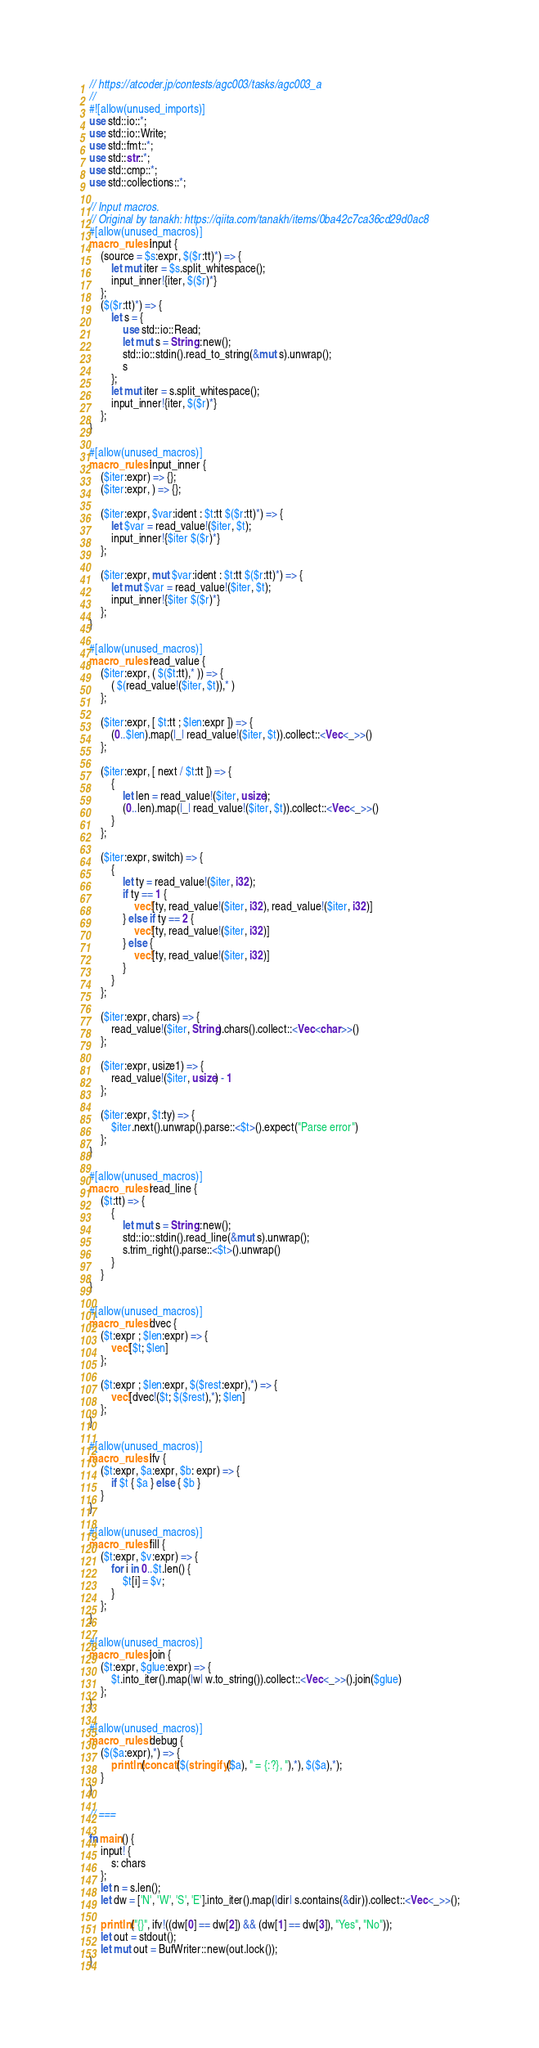Convert code to text. <code><loc_0><loc_0><loc_500><loc_500><_Rust_>// https://atcoder.jp/contests/agc003/tasks/agc003_a
//
#![allow(unused_imports)]
use std::io::*;
use std::io::Write;
use std::fmt::*;
use std::str::*;
use std::cmp::*;
use std::collections::*;

// Input macros.
// Original by tanakh: https://qiita.com/tanakh/items/0ba42c7ca36cd29d0ac8
#[allow(unused_macros)]
macro_rules! input {
    (source = $s:expr, $($r:tt)*) => {
        let mut iter = $s.split_whitespace();
        input_inner!{iter, $($r)*}
    };
    ($($r:tt)*) => {
        let s = {
            use std::io::Read;
            let mut s = String::new();
            std::io::stdin().read_to_string(&mut s).unwrap();
            s
        };
        let mut iter = s.split_whitespace();
        input_inner!{iter, $($r)*}
    };
}

#[allow(unused_macros)]
macro_rules! input_inner {
    ($iter:expr) => {};
    ($iter:expr, ) => {};

    ($iter:expr, $var:ident : $t:tt $($r:tt)*) => {
        let $var = read_value!($iter, $t);
        input_inner!{$iter $($r)*}
    };

    ($iter:expr, mut $var:ident : $t:tt $($r:tt)*) => {
        let mut $var = read_value!($iter, $t);
        input_inner!{$iter $($r)*}
    };
}

#[allow(unused_macros)]
macro_rules! read_value {
    ($iter:expr, ( $($t:tt),* )) => {
        ( $(read_value!($iter, $t)),* )
    };

    ($iter:expr, [ $t:tt ; $len:expr ]) => {
        (0..$len).map(|_| read_value!($iter, $t)).collect::<Vec<_>>()
    };

    ($iter:expr, [ next / $t:tt ]) => {
        {
            let len = read_value!($iter, usize);
            (0..len).map(|_| read_value!($iter, $t)).collect::<Vec<_>>()
        }
    };

    ($iter:expr, switch) => {
        {
            let ty = read_value!($iter, i32);
            if ty == 1 {
                vec![ty, read_value!($iter, i32), read_value!($iter, i32)]
            } else if ty == 2 {
                vec![ty, read_value!($iter, i32)]
            } else {
                vec![ty, read_value!($iter, i32)]
            }
        }
    };

    ($iter:expr, chars) => {
        read_value!($iter, String).chars().collect::<Vec<char>>()
    };

    ($iter:expr, usize1) => {
        read_value!($iter, usize) - 1
    };

    ($iter:expr, $t:ty) => {
        $iter.next().unwrap().parse::<$t>().expect("Parse error")
    };
}

#[allow(unused_macros)]
macro_rules! read_line {
    ($t:tt) => {
        {
            let mut s = String::new();
            std::io::stdin().read_line(&mut s).unwrap();
            s.trim_right().parse::<$t>().unwrap()
        }
    }
}

#[allow(unused_macros)]
macro_rules! dvec {
    ($t:expr ; $len:expr) => {
        vec![$t; $len]
    };

    ($t:expr ; $len:expr, $($rest:expr),*) => {
        vec![dvec!($t; $($rest),*); $len]
    };
}

#[allow(unused_macros)]
macro_rules! ifv {
    ($t:expr, $a:expr, $b: expr) => {
        if $t { $a } else { $b }
    }
}

#[allow(unused_macros)]
macro_rules! fill {
    ($t:expr, $v:expr) => {
        for i in 0..$t.len() {
            $t[i] = $v;
        }
    };
}

#[allow(unused_macros)]
macro_rules! join {
    ($t:expr, $glue:expr) => {
        $t.into_iter().map(|w| w.to_string()).collect::<Vec<_>>().join($glue)
    };
}

#[allow(unused_macros)]
macro_rules! debug {
    ($($a:expr),*) => {
        println!(concat!($(stringify!($a), " = {:?}, "),*), $($a),*);
    }
}

// ===

fn main() {
    input! {
        s: chars
    };
    let n = s.len();
    let dw = ['N', 'W', 'S', 'E'].into_iter().map(|dir| s.contains(&dir)).collect::<Vec<_>>();

    println!("{}", ifv!((dw[0] == dw[2]) && (dw[1] == dw[3]), "Yes", "No"));
    let out = stdout();
    let mut out = BufWriter::new(out.lock());
}
</code> 